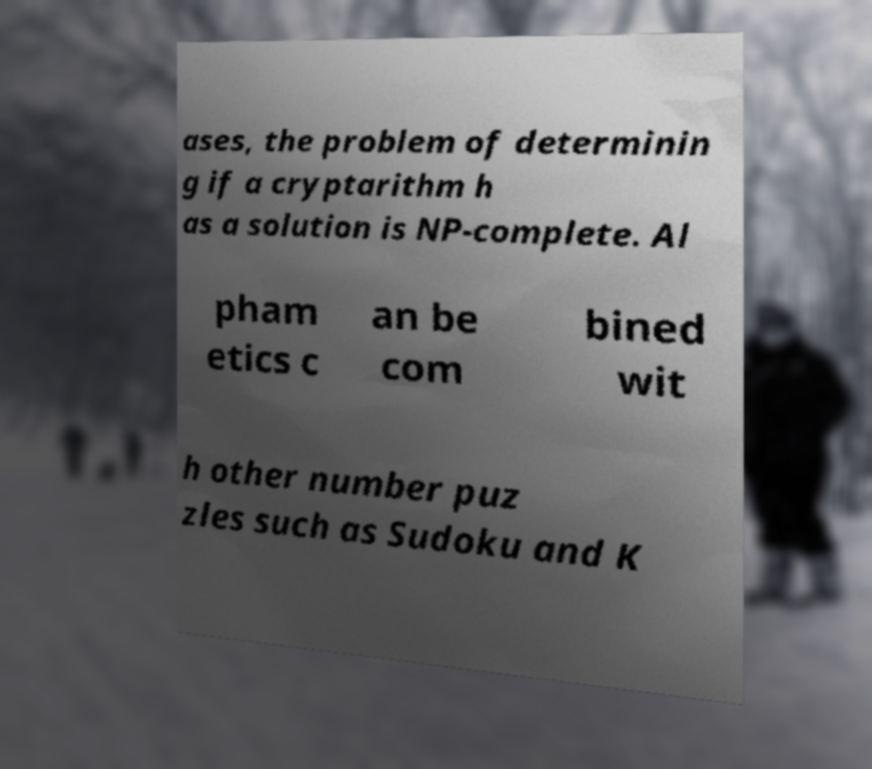Could you assist in decoding the text presented in this image and type it out clearly? ases, the problem of determinin g if a cryptarithm h as a solution is NP-complete. Al pham etics c an be com bined wit h other number puz zles such as Sudoku and K 